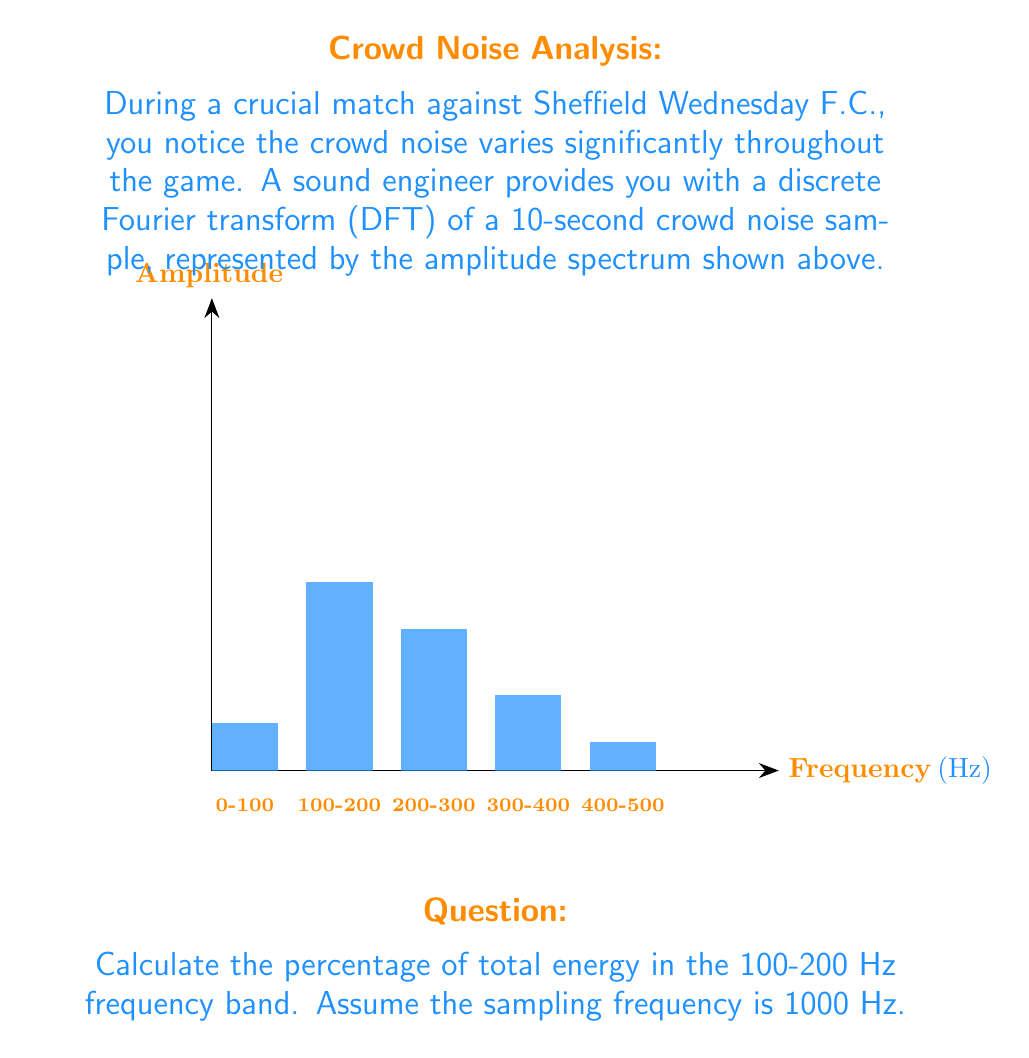What is the answer to this math problem? Let's approach this step-by-step:

1) In a DFT, the energy of a signal is proportional to the square of the amplitude. The total energy is the sum of energies in all frequency bands.

2) Calculate the energy in each frequency band:
   $E_i = A_i^2$, where $A_i$ is the amplitude of each band.
   
   $E_1 (0-100 Hz) = 0.5^2 = 0.25$
   $E_2 (100-200 Hz) = 2.0^2 = 4.00$
   $E_3 (200-300 Hz) = 1.5^2 = 2.25$
   $E_4 (300-400 Hz) = 0.8^2 = 0.64$
   $E_5 (400-500 Hz) = 0.3^2 = 0.09$

3) Calculate the total energy:
   $E_{total} = \sum_{i=1}^5 E_i = 0.25 + 4.00 + 2.25 + 0.64 + 0.09 = 7.23$

4) Calculate the energy in the 100-200 Hz band as a percentage of the total:
   $Percentage = \frac{E_2}{E_{total}} \times 100\% = \frac{4.00}{7.23} \times 100\% \approx 55.32\%$
Answer: 55.32% 